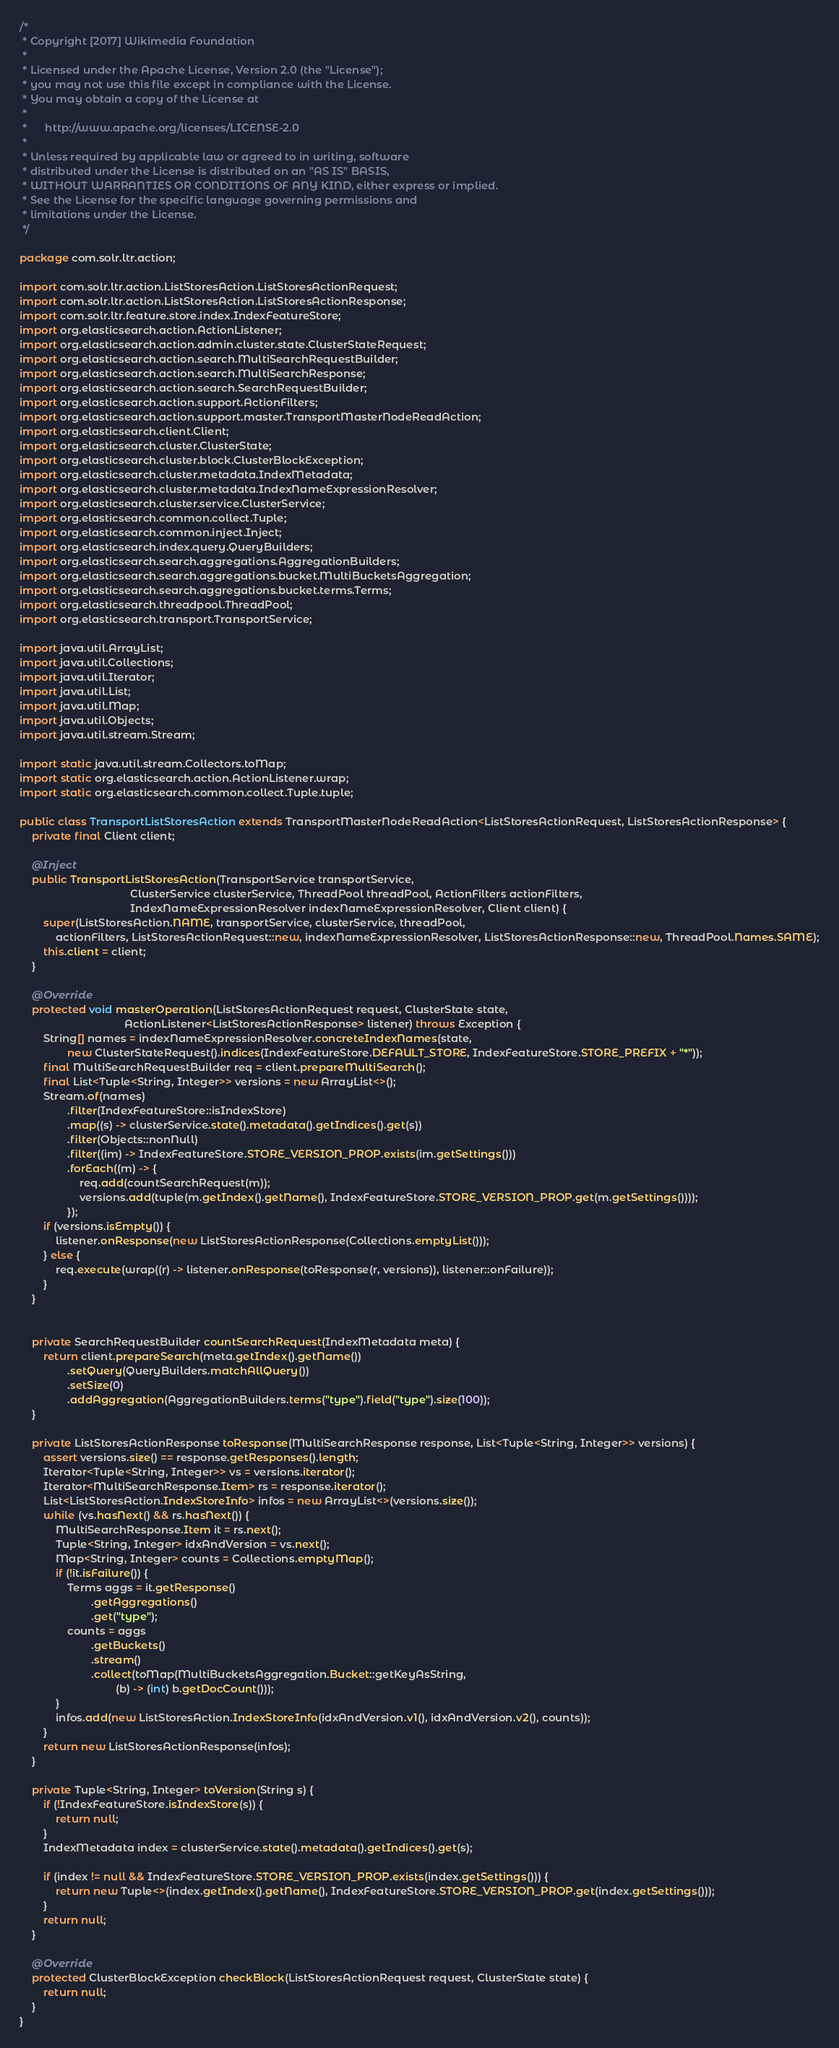<code> <loc_0><loc_0><loc_500><loc_500><_Java_>/*
 * Copyright [2017] Wikimedia Foundation
 *
 * Licensed under the Apache License, Version 2.0 (the "License");
 * you may not use this file except in compliance with the License.
 * You may obtain a copy of the License at
 *
 *      http://www.apache.org/licenses/LICENSE-2.0
 *
 * Unless required by applicable law or agreed to in writing, software
 * distributed under the License is distributed on an "AS IS" BASIS,
 * WITHOUT WARRANTIES OR CONDITIONS OF ANY KIND, either express or implied.
 * See the License for the specific language governing permissions and
 * limitations under the License.
 */

package com.solr.ltr.action;

import com.solr.ltr.action.ListStoresAction.ListStoresActionRequest;
import com.solr.ltr.action.ListStoresAction.ListStoresActionResponse;
import com.solr.ltr.feature.store.index.IndexFeatureStore;
import org.elasticsearch.action.ActionListener;
import org.elasticsearch.action.admin.cluster.state.ClusterStateRequest;
import org.elasticsearch.action.search.MultiSearchRequestBuilder;
import org.elasticsearch.action.search.MultiSearchResponse;
import org.elasticsearch.action.search.SearchRequestBuilder;
import org.elasticsearch.action.support.ActionFilters;
import org.elasticsearch.action.support.master.TransportMasterNodeReadAction;
import org.elasticsearch.client.Client;
import org.elasticsearch.cluster.ClusterState;
import org.elasticsearch.cluster.block.ClusterBlockException;
import org.elasticsearch.cluster.metadata.IndexMetadata;
import org.elasticsearch.cluster.metadata.IndexNameExpressionResolver;
import org.elasticsearch.cluster.service.ClusterService;
import org.elasticsearch.common.collect.Tuple;
import org.elasticsearch.common.inject.Inject;
import org.elasticsearch.index.query.QueryBuilders;
import org.elasticsearch.search.aggregations.AggregationBuilders;
import org.elasticsearch.search.aggregations.bucket.MultiBucketsAggregation;
import org.elasticsearch.search.aggregations.bucket.terms.Terms;
import org.elasticsearch.threadpool.ThreadPool;
import org.elasticsearch.transport.TransportService;

import java.util.ArrayList;
import java.util.Collections;
import java.util.Iterator;
import java.util.List;
import java.util.Map;
import java.util.Objects;
import java.util.stream.Stream;

import static java.util.stream.Collectors.toMap;
import static org.elasticsearch.action.ActionListener.wrap;
import static org.elasticsearch.common.collect.Tuple.tuple;

public class TransportListStoresAction extends TransportMasterNodeReadAction<ListStoresActionRequest, ListStoresActionResponse> {
    private final Client client;

    @Inject
    public TransportListStoresAction(TransportService transportService,
                                     ClusterService clusterService, ThreadPool threadPool, ActionFilters actionFilters,
                                     IndexNameExpressionResolver indexNameExpressionResolver, Client client) {
        super(ListStoresAction.NAME, transportService, clusterService, threadPool,
            actionFilters, ListStoresActionRequest::new, indexNameExpressionResolver, ListStoresActionResponse::new, ThreadPool.Names.SAME);
        this.client = client;
    }

    @Override
    protected void masterOperation(ListStoresActionRequest request, ClusterState state,
                                   ActionListener<ListStoresActionResponse> listener) throws Exception {
        String[] names = indexNameExpressionResolver.concreteIndexNames(state,
                new ClusterStateRequest().indices(IndexFeatureStore.DEFAULT_STORE, IndexFeatureStore.STORE_PREFIX + "*"));
        final MultiSearchRequestBuilder req = client.prepareMultiSearch();
        final List<Tuple<String, Integer>> versions = new ArrayList<>();
        Stream.of(names)
                .filter(IndexFeatureStore::isIndexStore)
                .map((s) -> clusterService.state().metadata().getIndices().get(s))
                .filter(Objects::nonNull)
                .filter((im) -> IndexFeatureStore.STORE_VERSION_PROP.exists(im.getSettings()))
                .forEach((m) -> {
                    req.add(countSearchRequest(m));
                    versions.add(tuple(m.getIndex().getName(), IndexFeatureStore.STORE_VERSION_PROP.get(m.getSettings())));
                });
        if (versions.isEmpty()) {
            listener.onResponse(new ListStoresActionResponse(Collections.emptyList()));
        } else {
            req.execute(wrap((r) -> listener.onResponse(toResponse(r, versions)), listener::onFailure));
        }
    }


    private SearchRequestBuilder countSearchRequest(IndexMetadata meta) {
        return client.prepareSearch(meta.getIndex().getName())
                .setQuery(QueryBuilders.matchAllQuery())
                .setSize(0)
                .addAggregation(AggregationBuilders.terms("type").field("type").size(100));
    }

    private ListStoresActionResponse toResponse(MultiSearchResponse response, List<Tuple<String, Integer>> versions) {
        assert versions.size() == response.getResponses().length;
        Iterator<Tuple<String, Integer>> vs = versions.iterator();
        Iterator<MultiSearchResponse.Item> rs = response.iterator();
        List<ListStoresAction.IndexStoreInfo> infos = new ArrayList<>(versions.size());
        while (vs.hasNext() && rs.hasNext()) {
            MultiSearchResponse.Item it = rs.next();
            Tuple<String, Integer> idxAndVersion = vs.next();
            Map<String, Integer> counts = Collections.emptyMap();
            if (!it.isFailure()) {
                Terms aggs = it.getResponse()
                        .getAggregations()
                        .get("type");
                counts = aggs
                        .getBuckets()
                        .stream()
                        .collect(toMap(MultiBucketsAggregation.Bucket::getKeyAsString,
                                (b) -> (int) b.getDocCount()));
            }
            infos.add(new ListStoresAction.IndexStoreInfo(idxAndVersion.v1(), idxAndVersion.v2(), counts));
        }
        return new ListStoresActionResponse(infos);
    }

    private Tuple<String, Integer> toVersion(String s) {
        if (!IndexFeatureStore.isIndexStore(s)) {
            return null;
        }
        IndexMetadata index = clusterService.state().metadata().getIndices().get(s);

        if (index != null && IndexFeatureStore.STORE_VERSION_PROP.exists(index.getSettings())) {
            return new Tuple<>(index.getIndex().getName(), IndexFeatureStore.STORE_VERSION_PROP.get(index.getSettings()));
        }
        return null;
    }

    @Override
    protected ClusterBlockException checkBlock(ListStoresActionRequest request, ClusterState state) {
        return null;
    }
}
</code> 